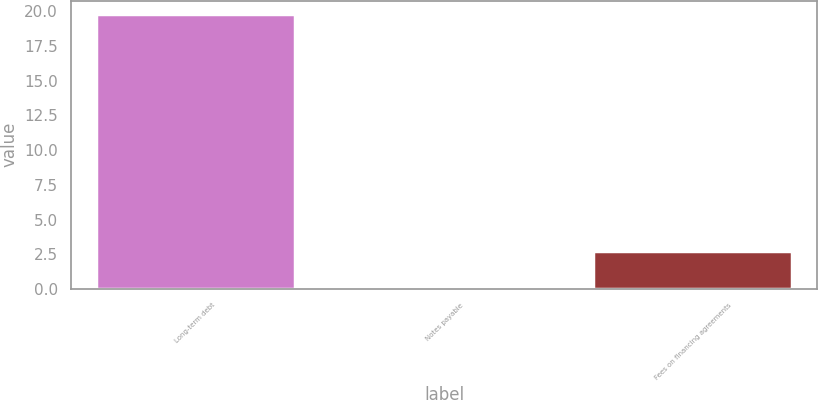<chart> <loc_0><loc_0><loc_500><loc_500><bar_chart><fcel>Long-term debt<fcel>Notes payable<fcel>Fees on financing agreements<nl><fcel>19.8<fcel>0.2<fcel>2.7<nl></chart> 